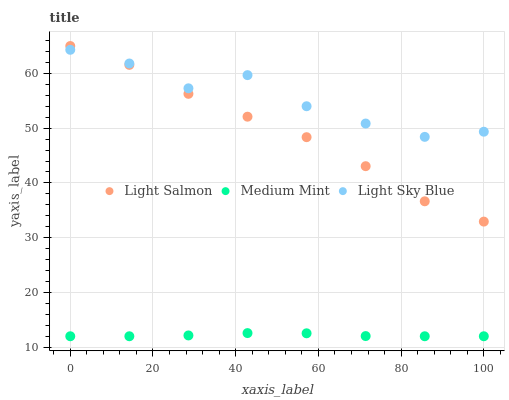Does Medium Mint have the minimum area under the curve?
Answer yes or no. Yes. Does Light Sky Blue have the maximum area under the curve?
Answer yes or no. Yes. Does Light Salmon have the minimum area under the curve?
Answer yes or no. No. Does Light Salmon have the maximum area under the curve?
Answer yes or no. No. Is Medium Mint the smoothest?
Answer yes or no. Yes. Is Light Sky Blue the roughest?
Answer yes or no. Yes. Is Light Salmon the smoothest?
Answer yes or no. No. Is Light Salmon the roughest?
Answer yes or no. No. Does Medium Mint have the lowest value?
Answer yes or no. Yes. Does Light Salmon have the lowest value?
Answer yes or no. No. Does Light Salmon have the highest value?
Answer yes or no. Yes. Does Light Sky Blue have the highest value?
Answer yes or no. No. Is Medium Mint less than Light Salmon?
Answer yes or no. Yes. Is Light Sky Blue greater than Medium Mint?
Answer yes or no. Yes. Does Light Salmon intersect Light Sky Blue?
Answer yes or no. Yes. Is Light Salmon less than Light Sky Blue?
Answer yes or no. No. Is Light Salmon greater than Light Sky Blue?
Answer yes or no. No. Does Medium Mint intersect Light Salmon?
Answer yes or no. No. 